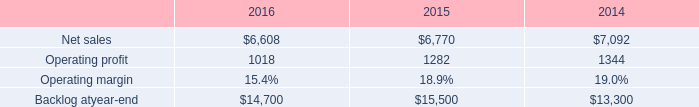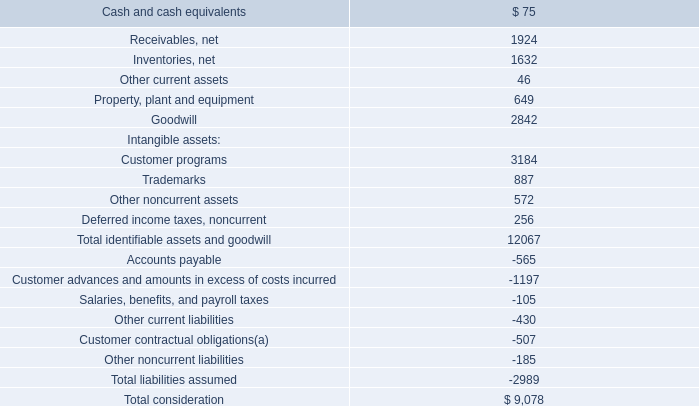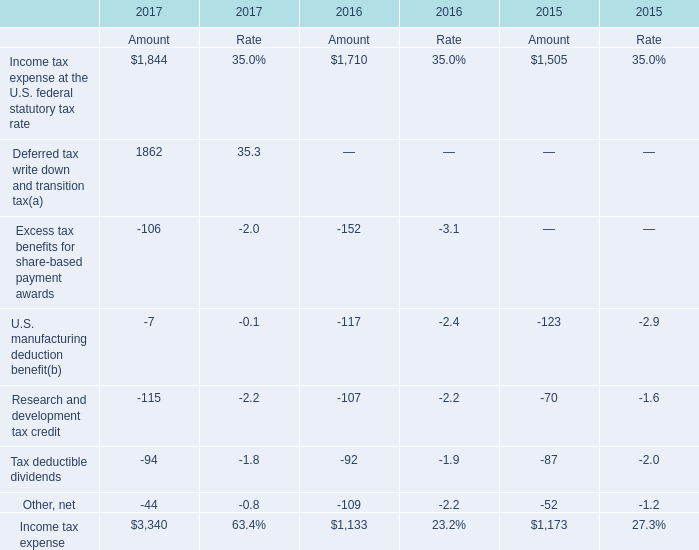What is the average value of Income tax expense in in 2015,2016,and 2017? 
Computations: (((3340 + 1133) + 1173) / 3)
Answer: 1882.0. 